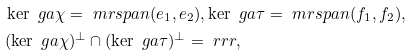<formula> <loc_0><loc_0><loc_500><loc_500>& \ker \ g a \chi = \ m r { s p a n } ( e _ { 1 } , e _ { 2 } ) , \ker \ g a \tau = \ m r { s p a n } ( f _ { 1 } , f _ { 2 } ) , \\ & ( \ker \ g a \chi ) ^ { \bot } \cap ( \ker \ g a \tau ) ^ { \bot } = \ r r r ,</formula> 